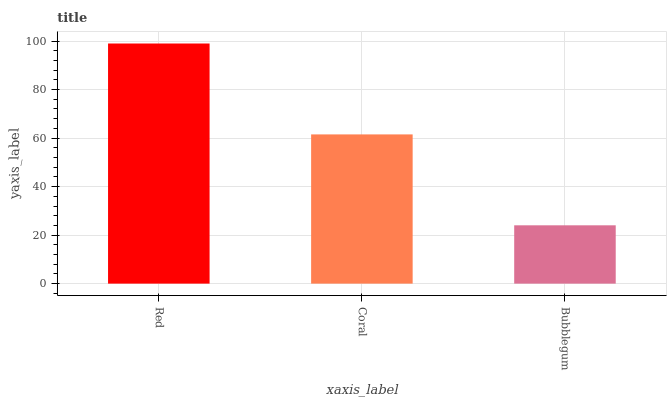Is Bubblegum the minimum?
Answer yes or no. Yes. Is Red the maximum?
Answer yes or no. Yes. Is Coral the minimum?
Answer yes or no. No. Is Coral the maximum?
Answer yes or no. No. Is Red greater than Coral?
Answer yes or no. Yes. Is Coral less than Red?
Answer yes or no. Yes. Is Coral greater than Red?
Answer yes or no. No. Is Red less than Coral?
Answer yes or no. No. Is Coral the high median?
Answer yes or no. Yes. Is Coral the low median?
Answer yes or no. Yes. Is Bubblegum the high median?
Answer yes or no. No. Is Red the low median?
Answer yes or no. No. 